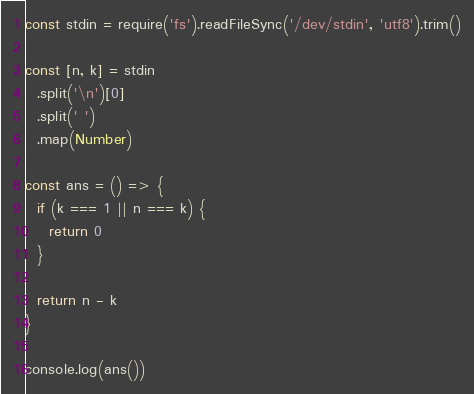Convert code to text. <code><loc_0><loc_0><loc_500><loc_500><_TypeScript_>const stdin = require('fs').readFileSync('/dev/stdin', 'utf8').trim()

const [n, k] = stdin
  .split('\n')[0]
  .split(' ')
  .map(Number)

const ans = () => {
  if (k === 1 || n === k) {
    return 0
  }

  return n - k
}

console.log(ans())
</code> 